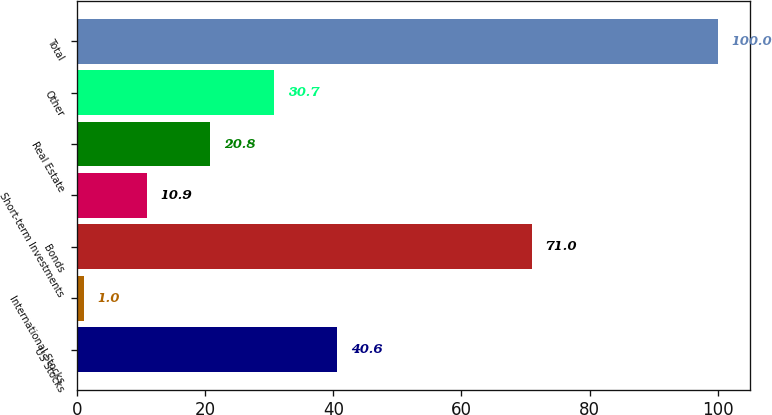<chart> <loc_0><loc_0><loc_500><loc_500><bar_chart><fcel>US Stocks<fcel>International Stocks<fcel>Bonds<fcel>Short-term Investments<fcel>Real Estate<fcel>Other<fcel>Total<nl><fcel>40.6<fcel>1<fcel>71<fcel>10.9<fcel>20.8<fcel>30.7<fcel>100<nl></chart> 